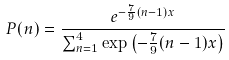<formula> <loc_0><loc_0><loc_500><loc_500>P ( n ) = \frac { e ^ { - \frac { 7 } { 9 } ( n - 1 ) x } } { \sum _ { n = 1 } ^ { 4 } \exp { \left ( - \frac { 7 } { 9 } ( n - 1 ) x \right ) } }</formula> 